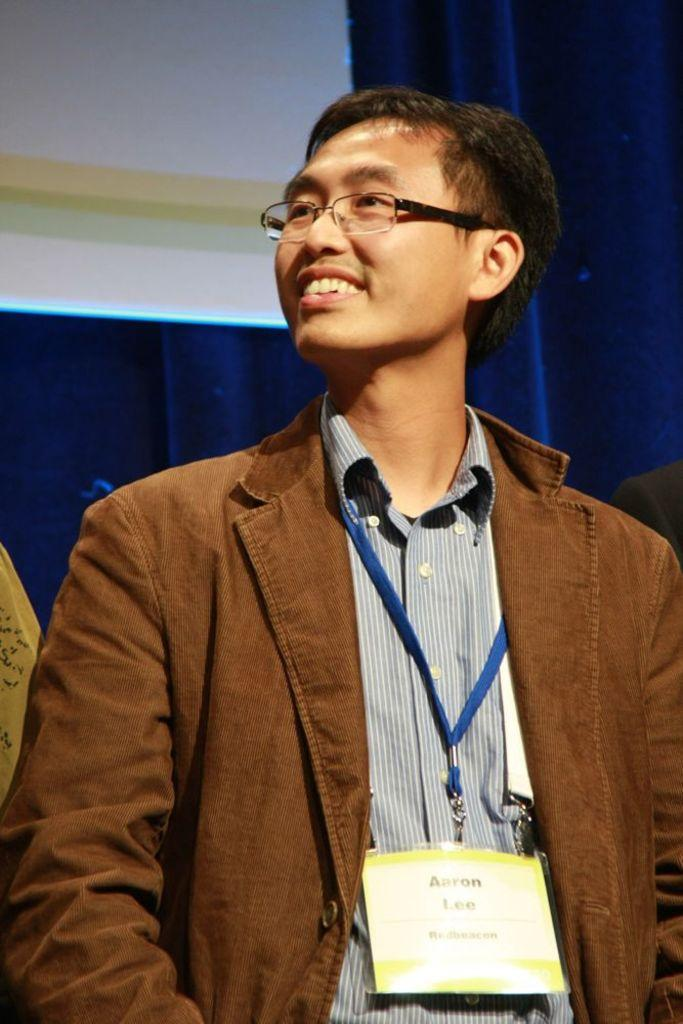Who or what is present in the image? There is a person in the image. What is the person wearing in the image? The person is wearing an ID card. What can be seen in the background of the image? There is a blue color curtain in the background of the image. How does the person rub the flame in the image? There is no flame present in the image, so the person cannot rub it. 